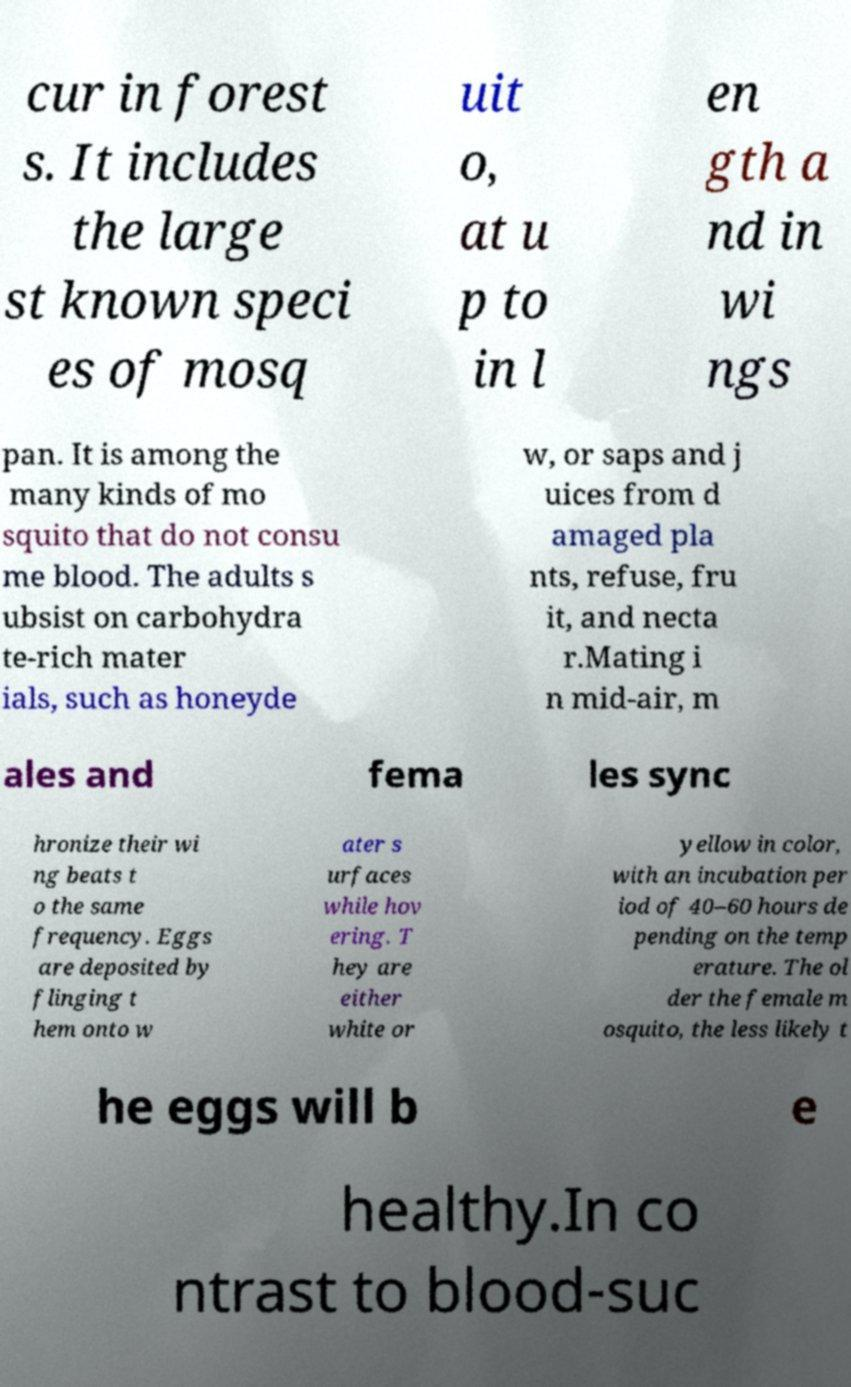What messages or text are displayed in this image? I need them in a readable, typed format. cur in forest s. It includes the large st known speci es of mosq uit o, at u p to in l en gth a nd in wi ngs pan. It is among the many kinds of mo squito that do not consu me blood. The adults s ubsist on carbohydra te-rich mater ials, such as honeyde w, or saps and j uices from d amaged pla nts, refuse, fru it, and necta r.Mating i n mid-air, m ales and fema les sync hronize their wi ng beats t o the same frequency. Eggs are deposited by flinging t hem onto w ater s urfaces while hov ering. T hey are either white or yellow in color, with an incubation per iod of 40–60 hours de pending on the temp erature. The ol der the female m osquito, the less likely t he eggs will b e healthy.In co ntrast to blood-suc 